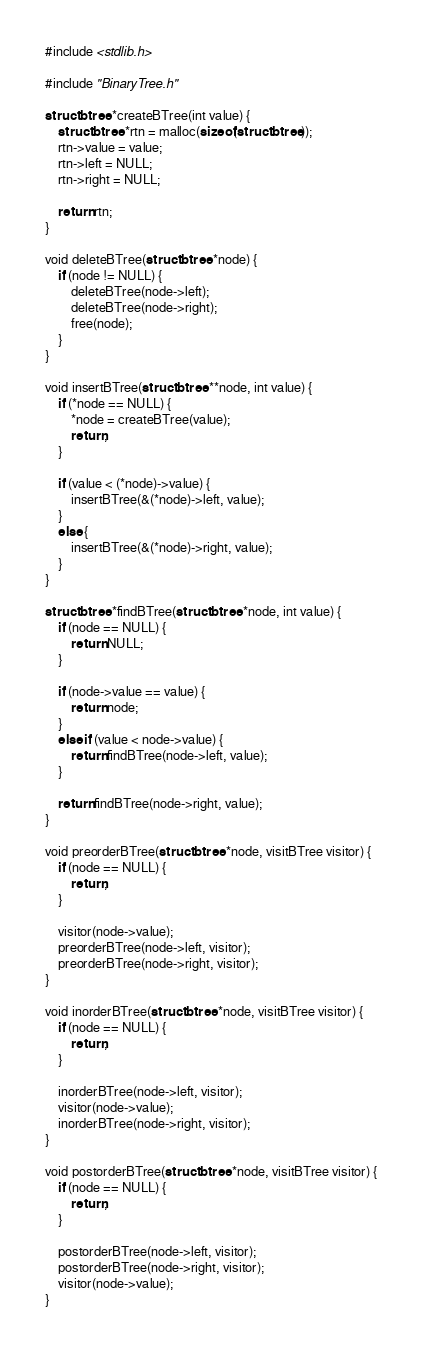Convert code to text. <code><loc_0><loc_0><loc_500><loc_500><_C_>#include <stdlib.h>

#include "BinaryTree.h"

struct btree *createBTree(int value) {
	struct btree *rtn = malloc(sizeof(struct btree));
	rtn->value = value;
	rtn->left = NULL;
	rtn->right = NULL;

	return rtn;
}

void deleteBTree(struct btree *node) {
	if (node != NULL) {
		deleteBTree(node->left);
		deleteBTree(node->right);
		free(node);
	}
}

void insertBTree(struct btree **node, int value) {
	if (*node == NULL) {
		*node = createBTree(value);
		return;
	}

	if (value < (*node)->value) {
		insertBTree(&(*node)->left, value);
	}
	else {
		insertBTree(&(*node)->right, value);
	}
}

struct btree *findBTree(struct btree *node, int value) {
	if (node == NULL) {
		return NULL;
	}

	if (node->value == value) {
		return node;
	}
	else if (value < node->value) {
		return findBTree(node->left, value);
	}
	
	return findBTree(node->right, value);
}

void preorderBTree(struct btree *node, visitBTree visitor) {
	if (node == NULL) {
		return;
	}

	visitor(node->value);
	preorderBTree(node->left, visitor);
	preorderBTree(node->right, visitor);
}

void inorderBTree(struct btree *node, visitBTree visitor) {
	if (node == NULL) {
		return;
	}

	inorderBTree(node->left, visitor);
	visitor(node->value);
	inorderBTree(node->right, visitor);
}

void postorderBTree(struct btree *node, visitBTree visitor) {
	if (node == NULL) {
		return;
	}

	postorderBTree(node->left, visitor);
	postorderBTree(node->right, visitor);
	visitor(node->value);
}
</code> 